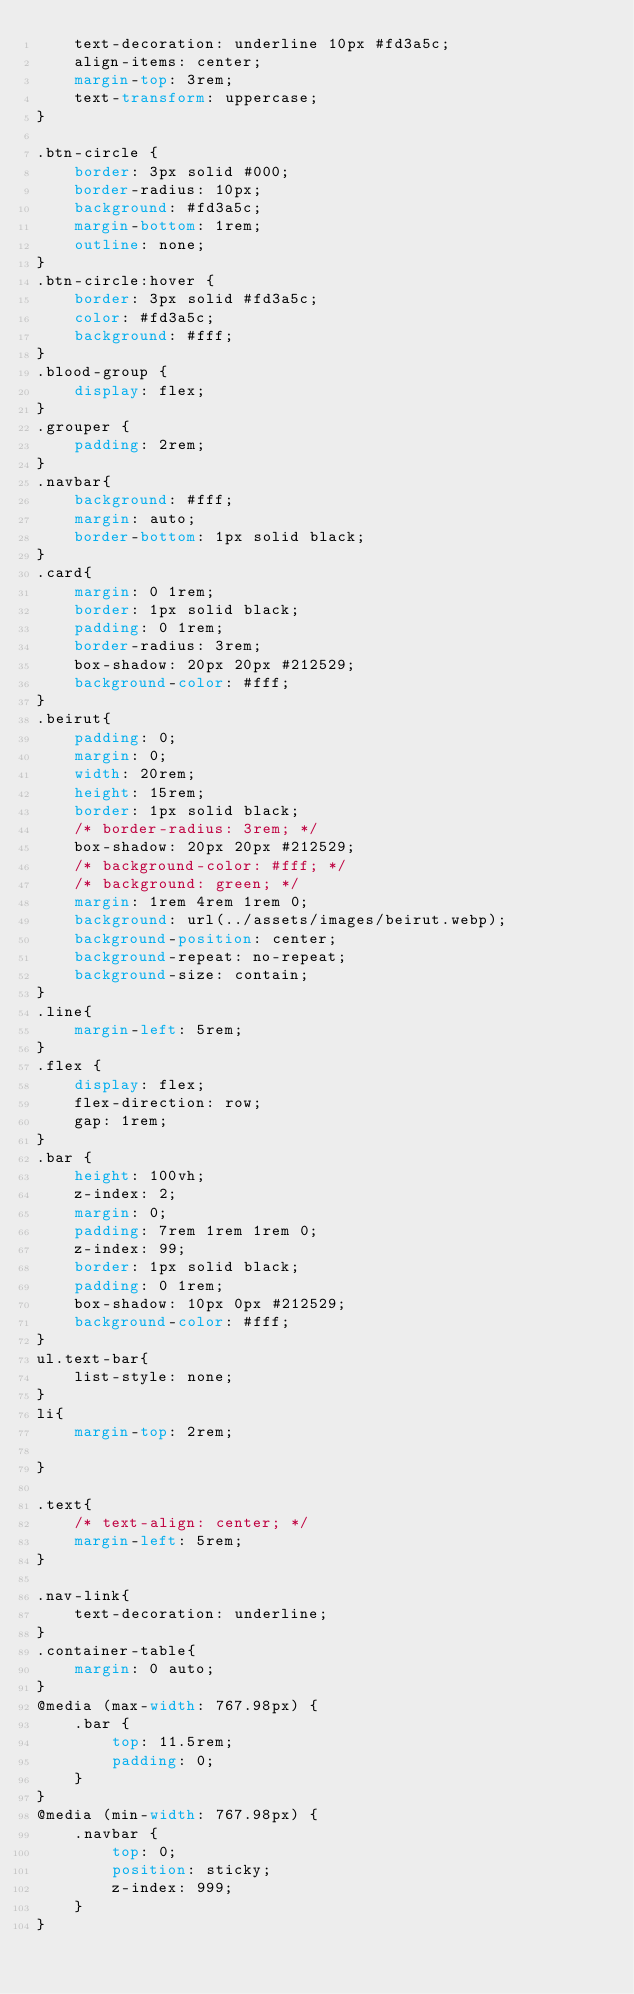<code> <loc_0><loc_0><loc_500><loc_500><_CSS_>	text-decoration: underline 10px #fd3a5c;
	align-items: center;
	margin-top: 3rem;
	text-transform: uppercase;
}

.btn-circle {
	border: 3px solid #000;
	border-radius: 10px;
	background: #fd3a5c;
	margin-bottom: 1rem;
	outline: none;
}
.btn-circle:hover {
	border: 3px solid #fd3a5c;
	color: #fd3a5c;
	background: #fff;
}
.blood-group {
	display: flex;
}
.grouper {
	padding: 2rem;
}
.navbar{
    background: #fff;
    margin: auto;
	border-bottom: 1px solid black;
}
.card{
    margin: 0 1rem;
	border: 1px solid black;
	padding: 0 1rem;
	border-radius: 3rem;
	box-shadow: 20px 20px #212529;
	background-color: #fff;
}
.beirut{
    padding: 0;
    margin: 0;
    width: 20rem;
    height: 15rem;
    border: 1px solid black;
	/* border-radius: 3rem; */
	box-shadow: 20px 20px #212529;
	/* background-color: #fff; */
    /* background: green; */
    margin: 1rem 4rem 1rem 0;
    background: url(../assets/images/beirut.webp);
    background-position: center;
    background-repeat: no-repeat;
    background-size: contain;
}
.line{
    margin-left: 5rem;
}
.flex {
    display: flex;
    flex-direction: row;
    gap: 1rem;    
}
.bar {
    height: 100vh;
    z-index: 2;
    margin: 0;
    padding: 7rem 1rem 1rem 0;
    z-index: 99;
	border: 1px solid black;
	padding: 0 1rem;
	box-shadow: 10px 0px #212529;
	background-color: #fff;
}
ul.text-bar{
    list-style: none;
}
li{
    margin-top: 2rem;

}

.text{
    /* text-align: center; */
    margin-left: 5rem;
}

.nav-link{
    text-decoration: underline;
}
.container-table{
    margin: 0 auto;
}
@media (max-width: 767.98px) {
    .bar {
        top: 11.5rem;
        padding: 0;
    }
}
@media (min-width: 767.98px) {
    .navbar {
        top: 0;
        position: sticky;
        z-index: 999;
    }
}
</code> 